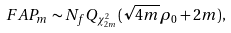Convert formula to latex. <formula><loc_0><loc_0><loc_500><loc_500>F A P _ { m } \sim N _ { f } Q _ { \chi ^ { 2 } _ { 2 m } } ( \sqrt { 4 m } \rho _ { 0 } + 2 m ) ,</formula> 